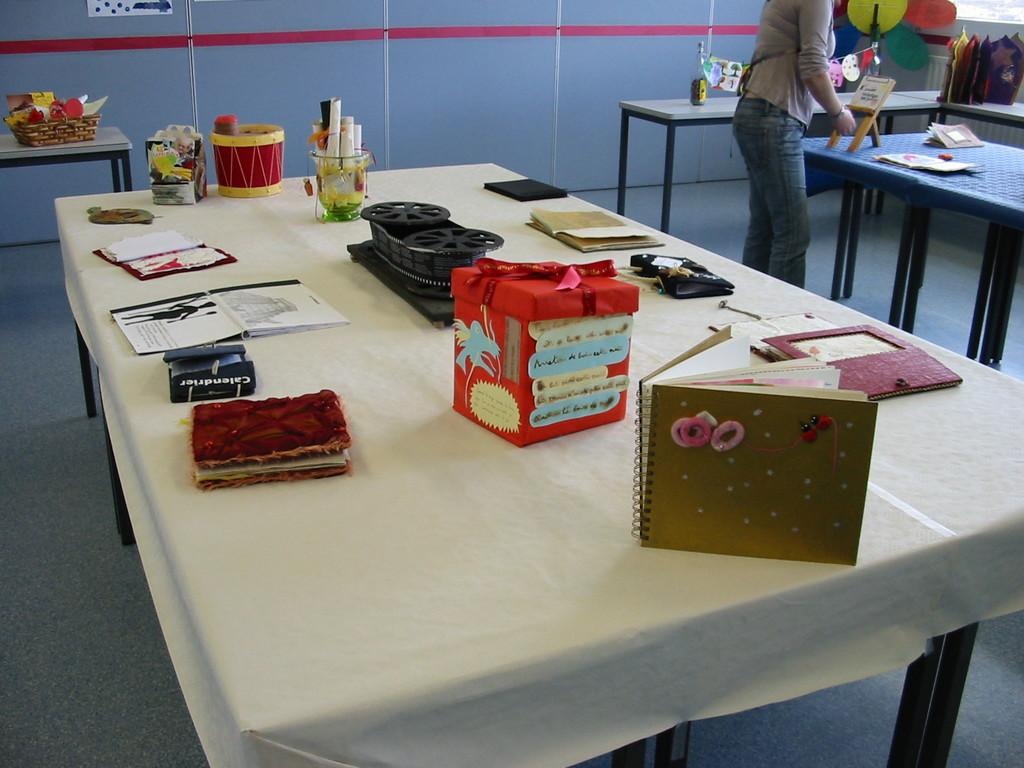What is the main piece of furniture in the image? There is a table in the image. What items can be seen on the table? There are cards, books, a box, wheels, a glass with rolled papers, a drum, and a basket on the table. Can you describe the person in the background? There is a person standing in the background, but no specific details about their appearance or actions are provided. What is the background of the image? There is a wall in the background. Are there any whips visible in the image? No, there are no whips present in the image. Can you see any fairies flying around the table? No, there are no fairies present in the image. 